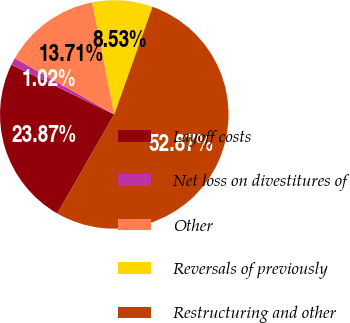Convert chart to OTSL. <chart><loc_0><loc_0><loc_500><loc_500><pie_chart><fcel>Layoff costs<fcel>Net loss on divestitures of<fcel>Other<fcel>Reversals of previously<fcel>Restructuring and other<nl><fcel>23.87%<fcel>1.02%<fcel>13.71%<fcel>8.53%<fcel>52.86%<nl></chart> 